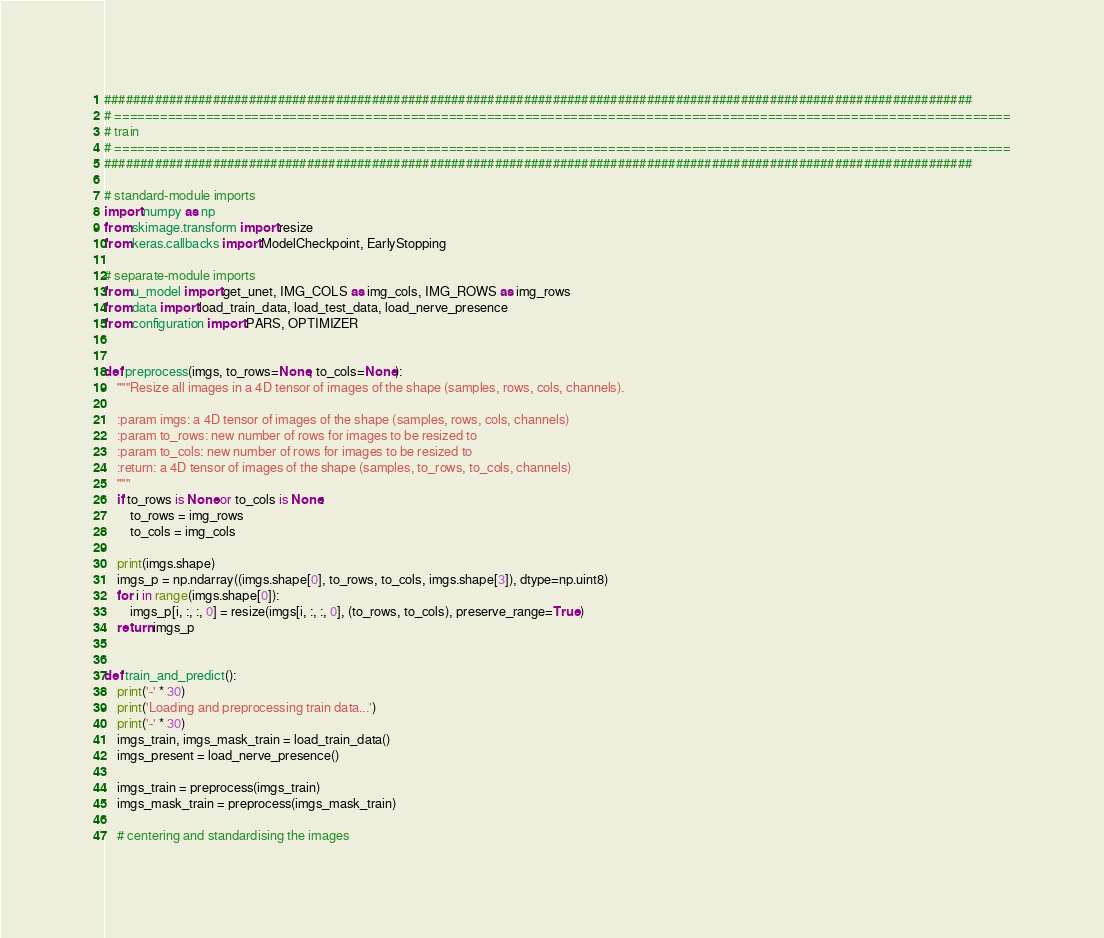Convert code to text. <code><loc_0><loc_0><loc_500><loc_500><_Python_>########################################################################################################################
# ======================================================================================================================
# train
# ======================================================================================================================
########################################################################################################################

# standard-module imports
import numpy as np
from skimage.transform import resize
from keras.callbacks import ModelCheckpoint, EarlyStopping

# separate-module imports
from u_model import get_unet, IMG_COLS as img_cols, IMG_ROWS as img_rows
from data import load_train_data, load_test_data, load_nerve_presence
from configuration import PARS, OPTIMIZER


def preprocess(imgs, to_rows=None, to_cols=None):
    """Resize all images in a 4D tensor of images of the shape (samples, rows, cols, channels).

    :param imgs: a 4D tensor of images of the shape (samples, rows, cols, channels)
    :param to_rows: new number of rows for images to be resized to
    :param to_cols: new number of rows for images to be resized to
    :return: a 4D tensor of images of the shape (samples, to_rows, to_cols, channels)
    """
    if to_rows is None or to_cols is None:
        to_rows = img_rows
        to_cols = img_cols

    print(imgs.shape)
    imgs_p = np.ndarray((imgs.shape[0], to_rows, to_cols, imgs.shape[3]), dtype=np.uint8)
    for i in range(imgs.shape[0]):
        imgs_p[i, :, :, 0] = resize(imgs[i, :, :, 0], (to_rows, to_cols), preserve_range=True)
    return imgs_p


def train_and_predict():
    print('-' * 30)
    print('Loading and preprocessing train data...')
    print('-' * 30)
    imgs_train, imgs_mask_train = load_train_data()
    imgs_present = load_nerve_presence()

    imgs_train = preprocess(imgs_train)
    imgs_mask_train = preprocess(imgs_mask_train)

    # centering and standardising the images</code> 